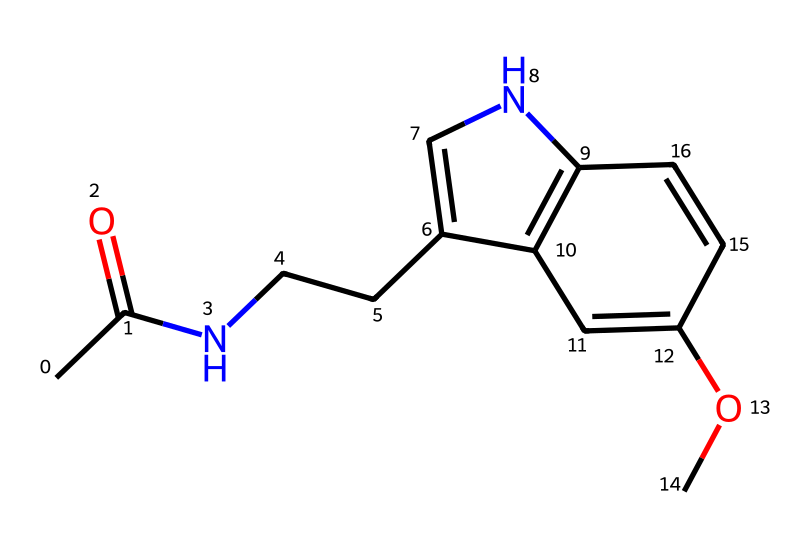What is the molecular formula of melatonin? The SMILES representation can be analyzed to count the number of each type of atom present. In this case, we have 13 carbon (C), 16 hydrogen (H), 1 nitrogen (N), and 2 oxygen (O) atoms. Thus, combining these gives the molecular formula C13H16N2O2.
Answer: C13H16N2O2 How many nitrogen atoms are in the structure? By closely examining the SMILES representation, we can identify that there are two nitrogen atoms represented in the sequence, specifically in the part of the structure that contains the amine functionalities.
Answer: 2 What type of hormone is melatonin? Melatonin is classified as a neurohormone based on its production in the pineal gland and its role in regulating sleep patterns in the body.
Answer: neurohormone What functional groups are present in melatonin? Analyzing the structure shows that melatonin contains an acetamide group due to the presence of the carbonyl (C=O) adjacent to nitrogen and a methoxy group due to the O-CH3 group attached in the structure.
Answer: acetamide and methoxy What is the dominant structural feature of melatonin? The structure features a central indole ring, which is a key component contributing to its biological activity and classification as an indole derivative.
Answer: indole ring Which part of melatonin is responsible for its sleep-regulating function? The indole structure in melatonin is crucial as it enables bonding to receptors in the brain that control sleep cycles and circadian rhythms.
Answer: indole structure 